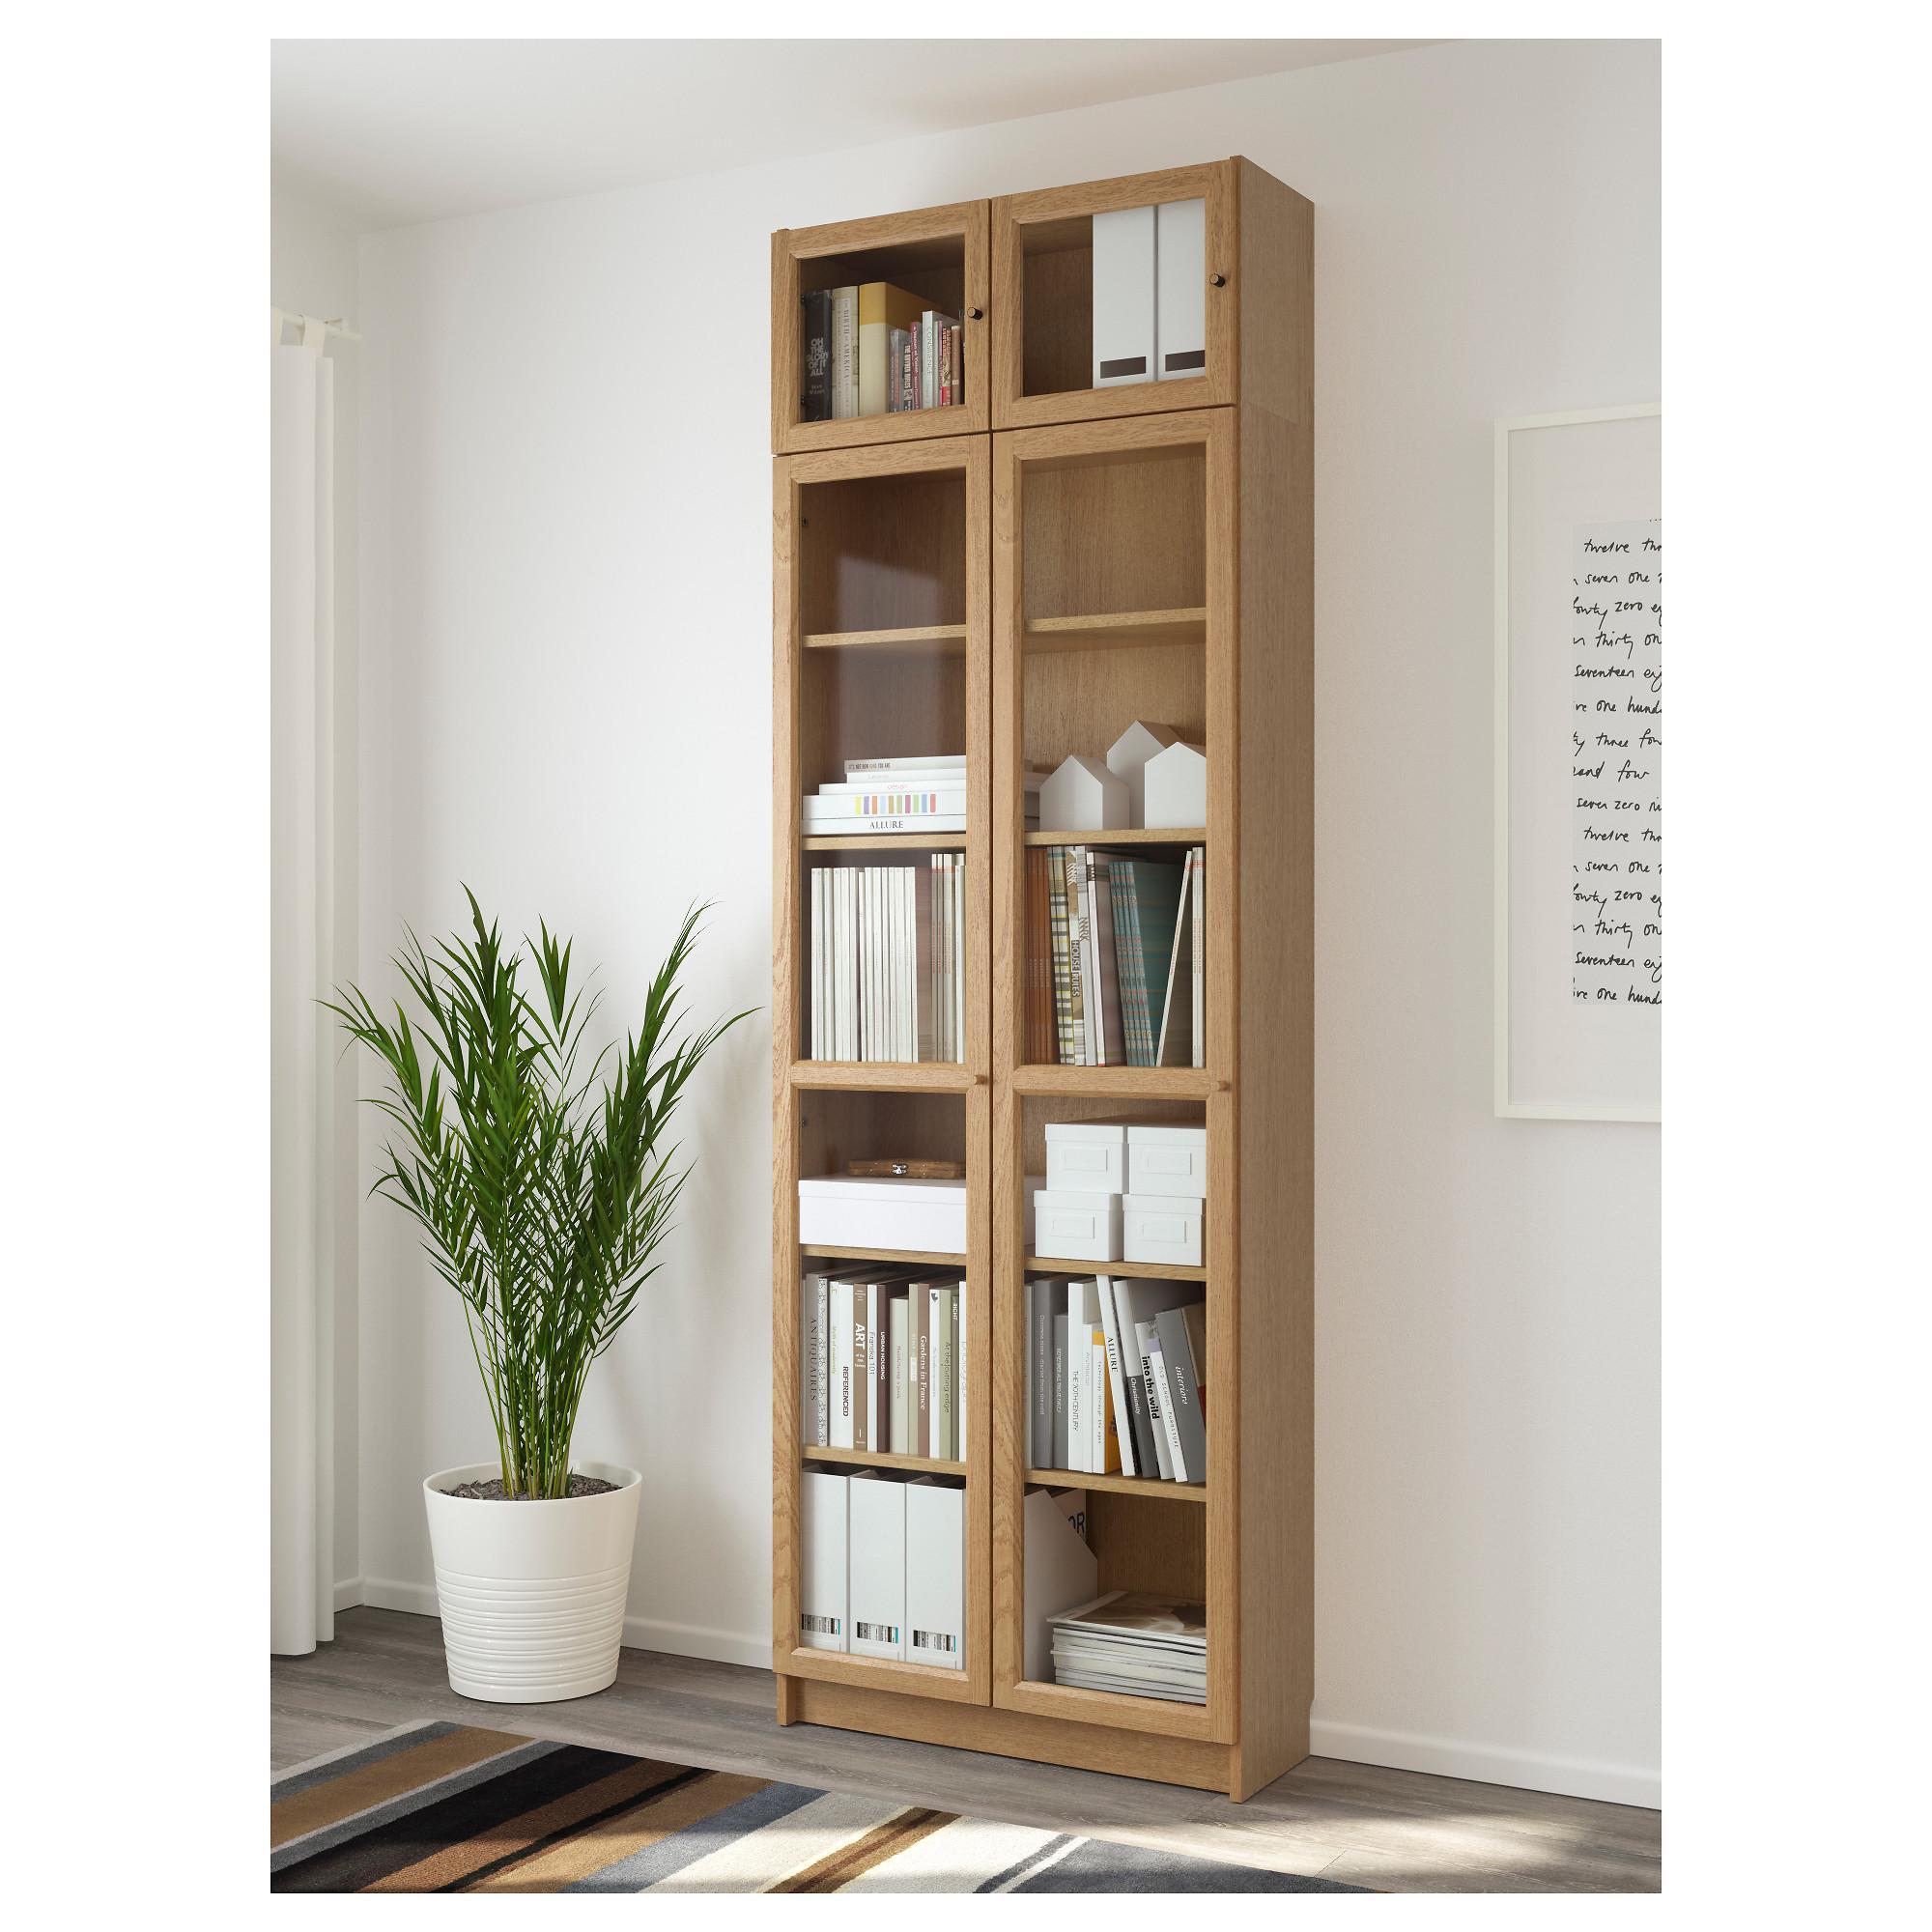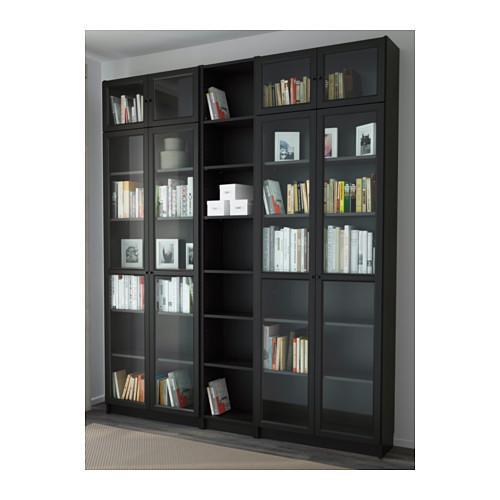The first image is the image on the left, the second image is the image on the right. For the images shown, is this caption "A single white lamp hangs down from the ceiling in one of the images." true? Answer yes or no. No. 